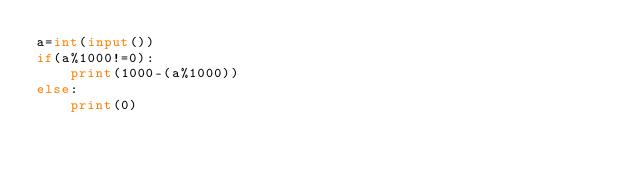<code> <loc_0><loc_0><loc_500><loc_500><_Python_>a=int(input())
if(a%1000!=0):
    print(1000-(a%1000))
else:
    print(0)</code> 